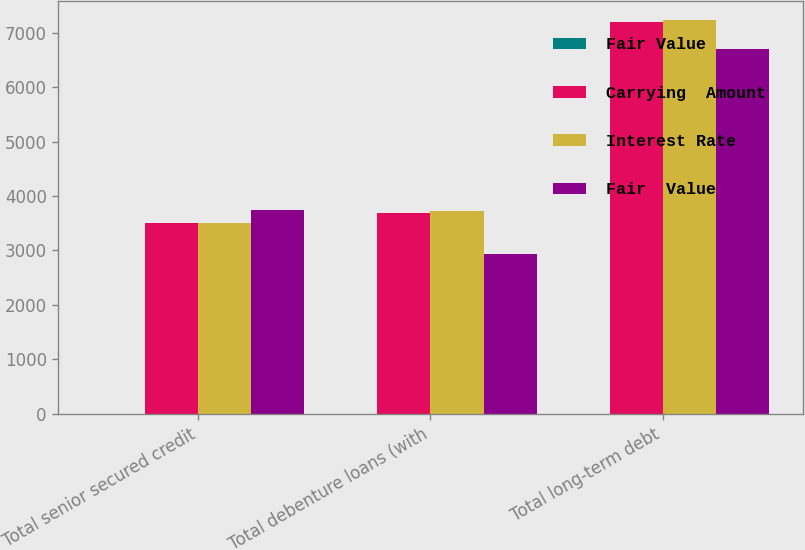Convert chart to OTSL. <chart><loc_0><loc_0><loc_500><loc_500><stacked_bar_chart><ecel><fcel>Total senior secured credit<fcel>Total debenture loans (with<fcel>Total long-term debt<nl><fcel>Fair Value<fcel>2.78<fcel>5.22<fcel>4.04<nl><fcel>Carrying  Amount<fcel>3496<fcel>3693<fcel>7196<nl><fcel>Interest Rate<fcel>3497<fcel>3718<fcel>7222<nl><fcel>Fair  Value<fcel>3742<fcel>2944<fcel>6694<nl></chart> 